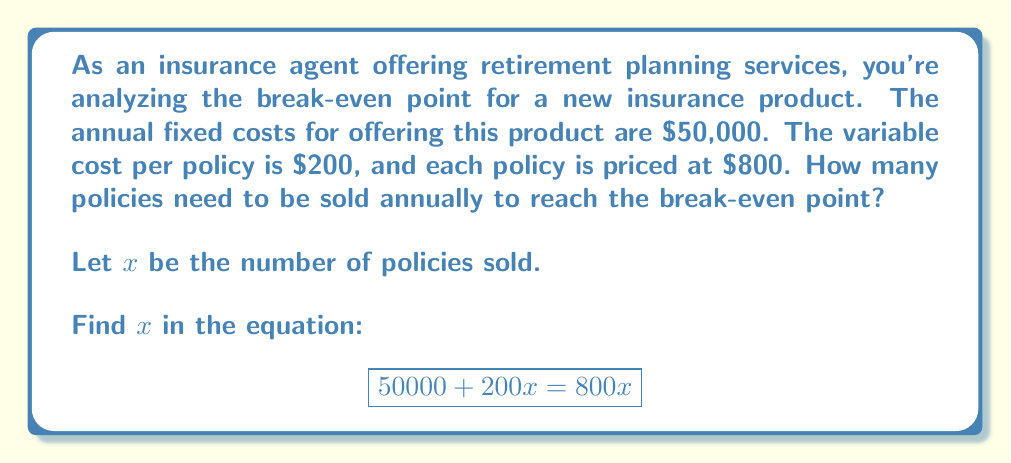Show me your answer to this math problem. To solve this problem, we'll follow these steps:

1) First, let's understand what the break-even point means. It's the point where total revenue equals total costs.

2) We can express this as an equation:
   Total Revenue = Total Costs

3) In this case:
   - Total Revenue = Price per policy × Number of policies
   - Total Costs = Fixed costs + (Variable cost per policy × Number of policies)

4) Let $x$ be the number of policies sold. We can now write our equation:
   $$800x = 50000 + 200x$$

5) To solve for $x$, we first subtract $200x$ from both sides:
   $$600x = 50000$$

6) Now, divide both sides by 600:
   $$x = \frac{50000}{600} = \frac{25000}{300}$$

7) Simplify the fraction:
   $$x = \frac{250}{3} \approx 83.33$$

8) Since we can't sell a fraction of a policy, we round up to the nearest whole number.
Answer: The company needs to sell 84 policies annually to reach the break-even point. 